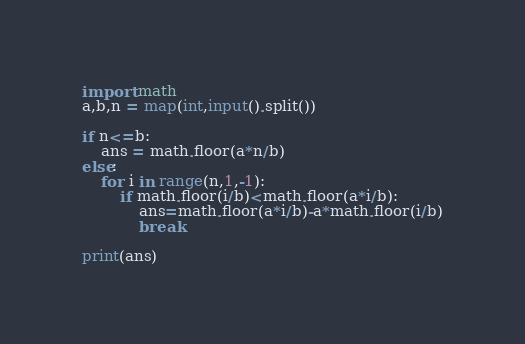<code> <loc_0><loc_0><loc_500><loc_500><_Python_>import math
a,b,n = map(int,input().split())

if n<=b:
    ans = math.floor(a*n/b)
else:
    for i in range(n,1,-1):
        if math.floor(i/b)<math.floor(a*i/b):
            ans=math.floor(a*i/b)-a*math.floor(i/b)
            break

print(ans)</code> 